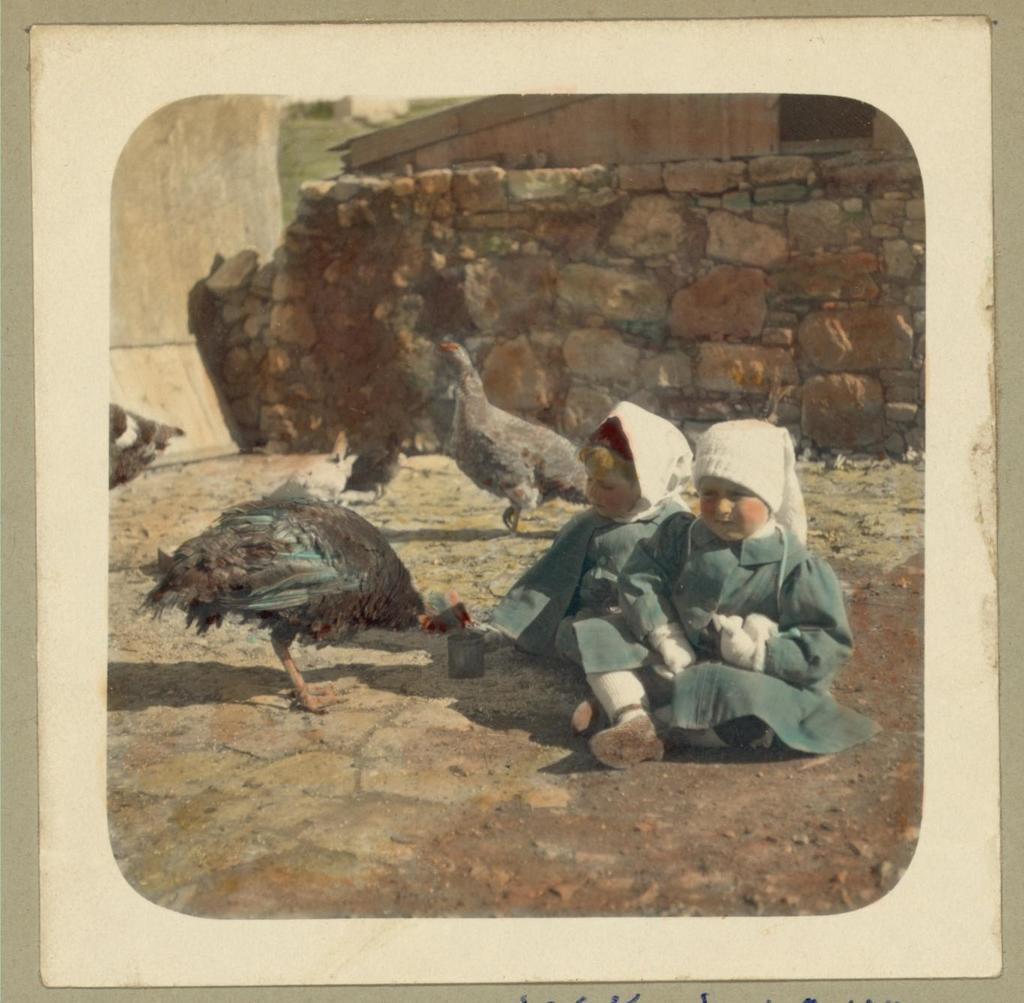In one or two sentences, can you explain what this image depicts? This looks like an edited image. I can see two girls sitting. I think these are the hens. In the background, this looks like a wall, which is built with the rocks. 